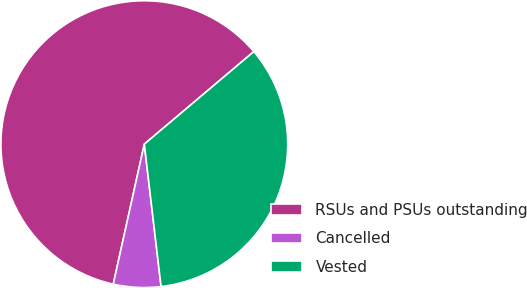Convert chart. <chart><loc_0><loc_0><loc_500><loc_500><pie_chart><fcel>RSUs and PSUs outstanding<fcel>Cancelled<fcel>Vested<nl><fcel>60.35%<fcel>5.34%<fcel>34.3%<nl></chart> 